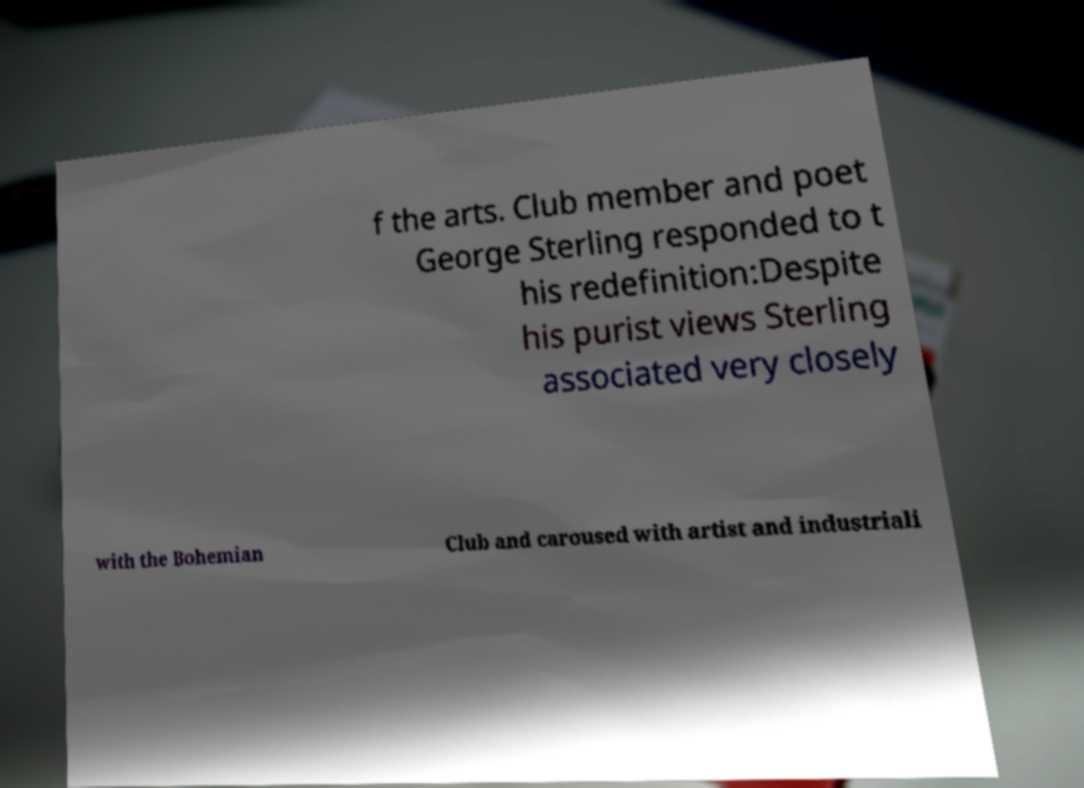Please identify and transcribe the text found in this image. f the arts. Club member and poet George Sterling responded to t his redefinition:Despite his purist views Sterling associated very closely with the Bohemian Club and caroused with artist and industriali 